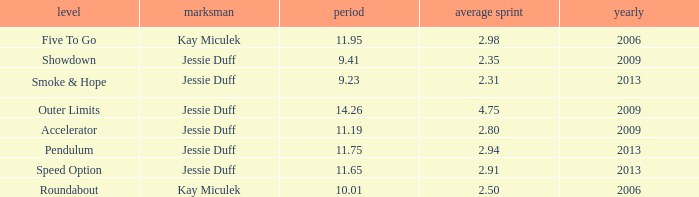What is the total amount of time for years prior to 2013 when speed option is the stage? None. 